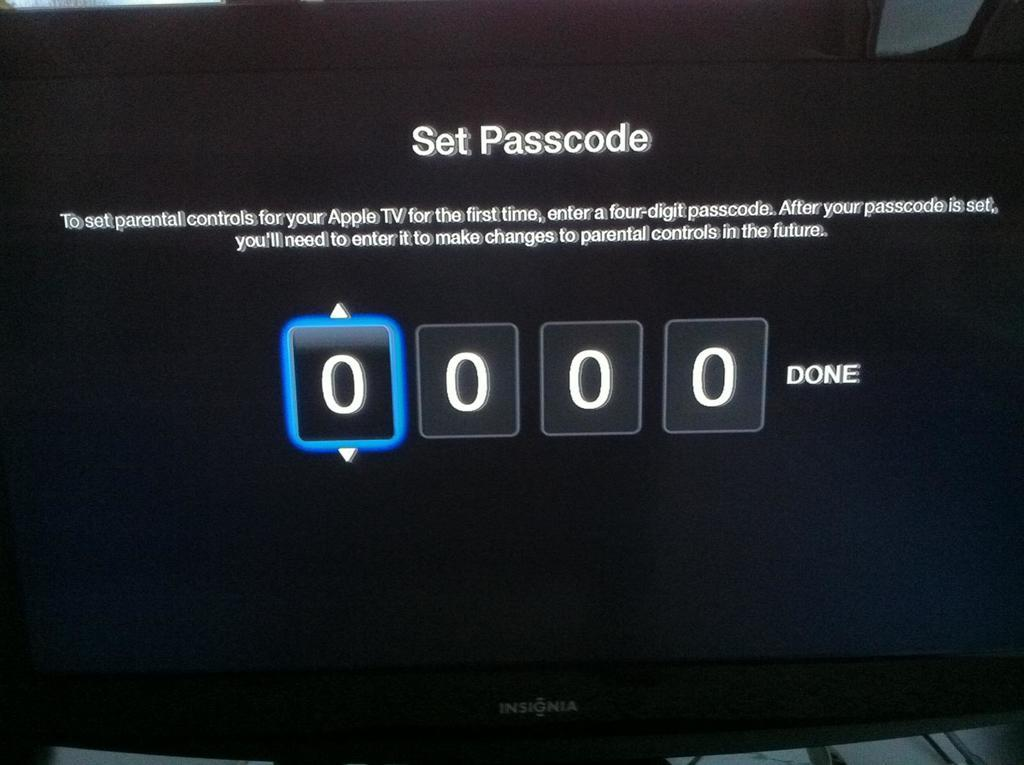Provide a one-sentence caption for the provided image. A video screen displaying the instructions on how to set the password up. 